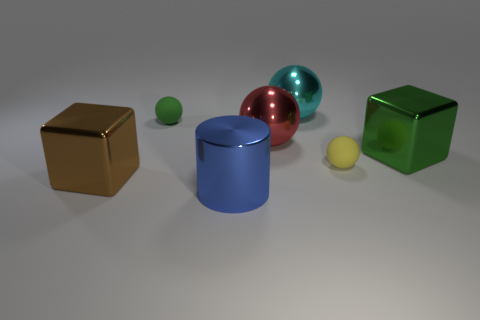What number of small brown rubber cylinders are there?
Your answer should be very brief. 0. What color is the cylinder that is made of the same material as the large cyan object?
Offer a terse response. Blue. Is the number of big blue metal cylinders greater than the number of large blue rubber objects?
Make the answer very short. Yes. What is the size of the object that is on the right side of the large blue cylinder and behind the big red thing?
Provide a succinct answer. Large. Are there the same number of blue metallic things that are in front of the small yellow sphere and purple balls?
Your response must be concise. No. Is the size of the red object the same as the green sphere?
Offer a very short reply. No. There is a sphere that is on the right side of the tiny green rubber object and behind the red metallic object; what is its color?
Provide a short and direct response. Cyan. The tiny thing that is to the right of the tiny thing left of the big cylinder is made of what material?
Keep it short and to the point. Rubber. What size is the cyan thing that is the same shape as the red thing?
Your response must be concise. Large. Are there fewer cyan shiny cubes than big blue cylinders?
Your answer should be very brief. Yes. 